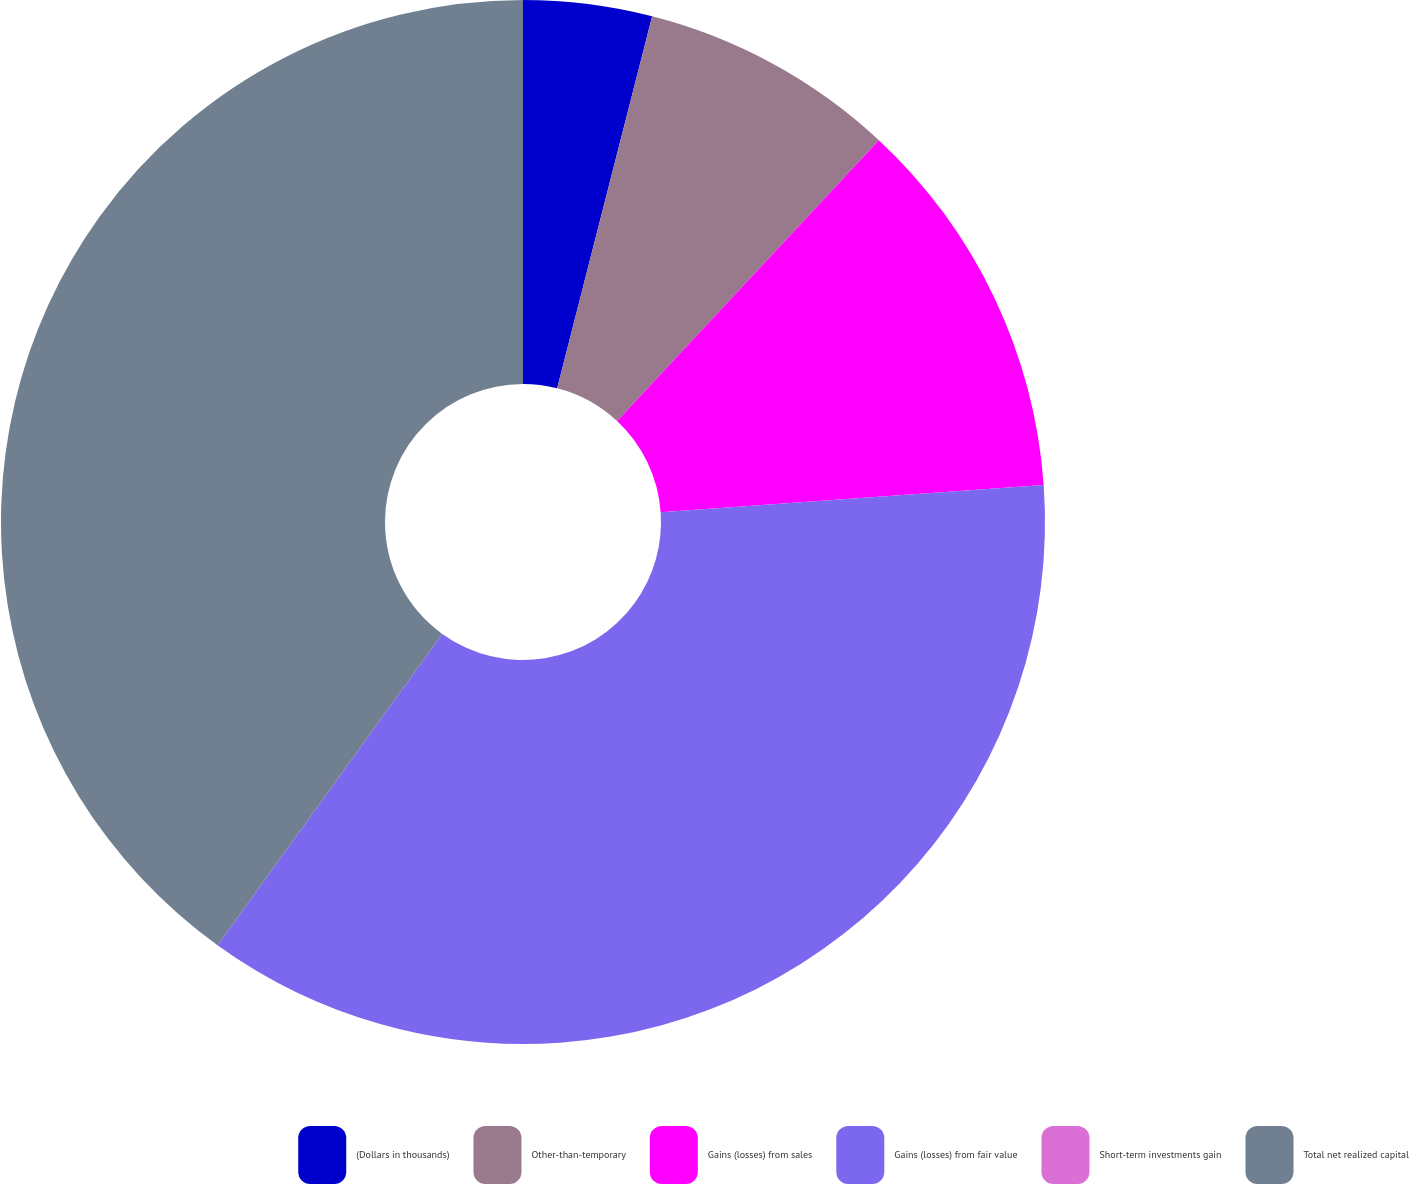Convert chart to OTSL. <chart><loc_0><loc_0><loc_500><loc_500><pie_chart><fcel>(Dollars in thousands)<fcel>Other-than-temporary<fcel>Gains (losses) from sales<fcel>Gains (losses) from fair value<fcel>Short-term investments gain<fcel>Total net realized capital<nl><fcel>3.98%<fcel>7.96%<fcel>11.93%<fcel>36.08%<fcel>0.0%<fcel>40.05%<nl></chart> 